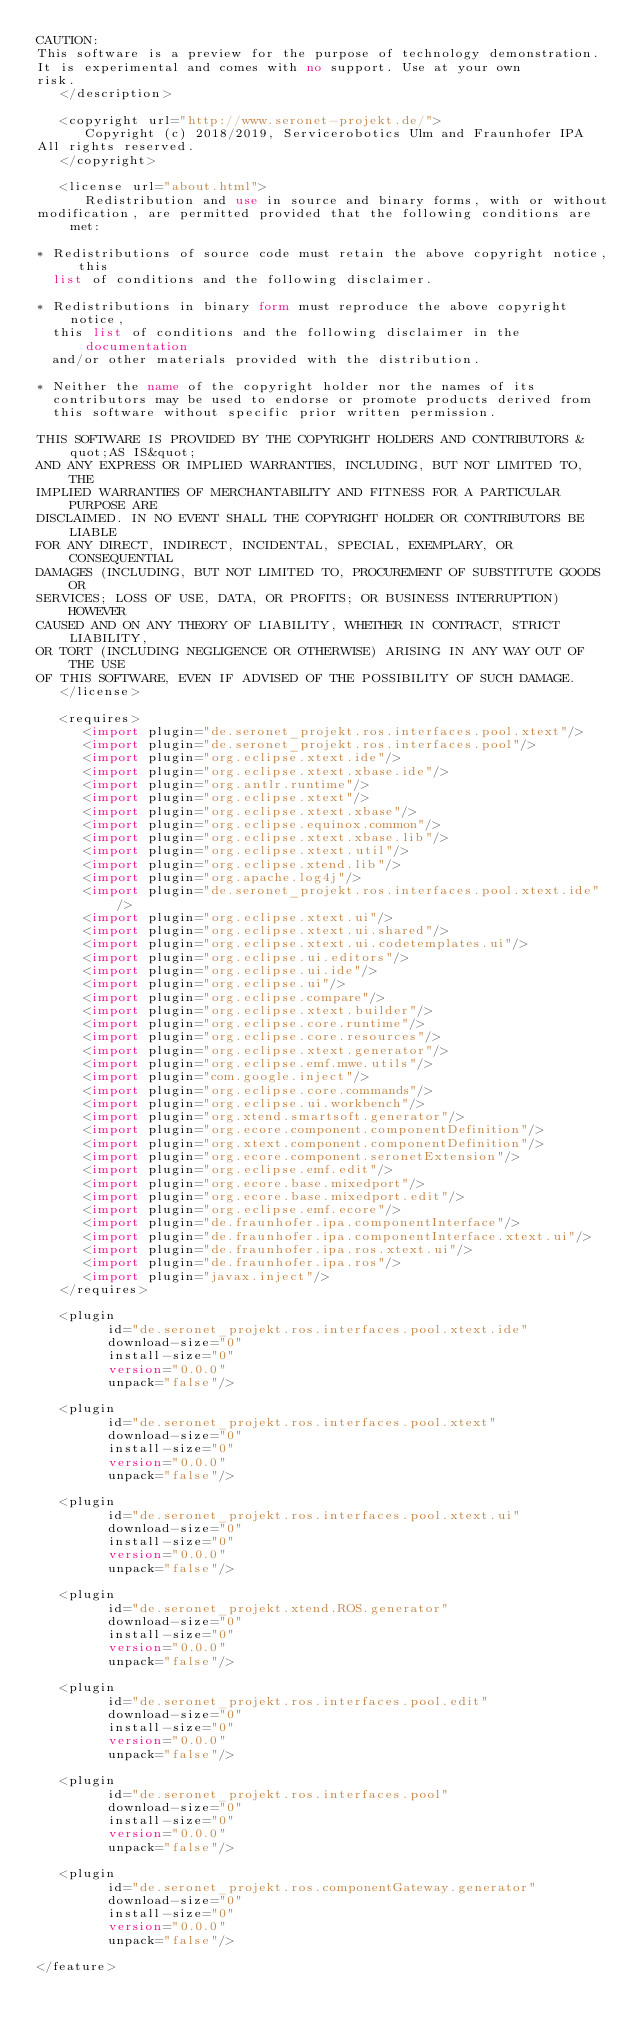Convert code to text. <code><loc_0><loc_0><loc_500><loc_500><_XML_>CAUTION: 
This software is a preview for the purpose of technology demonstration.
It is experimental and comes with no support. Use at your own
risk.
   </description>

   <copyright url="http://www.seronet-projekt.de/">
      Copyright (c) 2018/2019, Servicerobotics Ulm and Fraunhofer IPA
All rights reserved.
   </copyright>

   <license url="about.html">
      Redistribution and use in source and binary forms, with or without
modification, are permitted provided that the following conditions are met:

* Redistributions of source code must retain the above copyright notice, this
  list of conditions and the following disclaimer.

* Redistributions in binary form must reproduce the above copyright notice,
  this list of conditions and the following disclaimer in the documentation
  and/or other materials provided with the distribution.

* Neither the name of the copyright holder nor the names of its
  contributors may be used to endorse or promote products derived from
  this software without specific prior written permission.

THIS SOFTWARE IS PROVIDED BY THE COPYRIGHT HOLDERS AND CONTRIBUTORS &quot;AS IS&quot;
AND ANY EXPRESS OR IMPLIED WARRANTIES, INCLUDING, BUT NOT LIMITED TO, THE
IMPLIED WARRANTIES OF MERCHANTABILITY AND FITNESS FOR A PARTICULAR PURPOSE ARE
DISCLAIMED. IN NO EVENT SHALL THE COPYRIGHT HOLDER OR CONTRIBUTORS BE LIABLE
FOR ANY DIRECT, INDIRECT, INCIDENTAL, SPECIAL, EXEMPLARY, OR CONSEQUENTIAL
DAMAGES (INCLUDING, BUT NOT LIMITED TO, PROCUREMENT OF SUBSTITUTE GOODS OR
SERVICES; LOSS OF USE, DATA, OR PROFITS; OR BUSINESS INTERRUPTION) HOWEVER
CAUSED AND ON ANY THEORY OF LIABILITY, WHETHER IN CONTRACT, STRICT LIABILITY,
OR TORT (INCLUDING NEGLIGENCE OR OTHERWISE) ARISING IN ANY WAY OUT OF THE USE
OF THIS SOFTWARE, EVEN IF ADVISED OF THE POSSIBILITY OF SUCH DAMAGE.
   </license>

   <requires>
      <import plugin="de.seronet_projekt.ros.interfaces.pool.xtext"/>
      <import plugin="de.seronet_projekt.ros.interfaces.pool"/>
      <import plugin="org.eclipse.xtext.ide"/>
      <import plugin="org.eclipse.xtext.xbase.ide"/>
      <import plugin="org.antlr.runtime"/>
      <import plugin="org.eclipse.xtext"/>
      <import plugin="org.eclipse.xtext.xbase"/>
      <import plugin="org.eclipse.equinox.common"/>
      <import plugin="org.eclipse.xtext.xbase.lib"/>
      <import plugin="org.eclipse.xtext.util"/>
      <import plugin="org.eclipse.xtend.lib"/>
      <import plugin="org.apache.log4j"/>
      <import plugin="de.seronet_projekt.ros.interfaces.pool.xtext.ide"/>
      <import plugin="org.eclipse.xtext.ui"/>
      <import plugin="org.eclipse.xtext.ui.shared"/>
      <import plugin="org.eclipse.xtext.ui.codetemplates.ui"/>
      <import plugin="org.eclipse.ui.editors"/>
      <import plugin="org.eclipse.ui.ide"/>
      <import plugin="org.eclipse.ui"/>
      <import plugin="org.eclipse.compare"/>
      <import plugin="org.eclipse.xtext.builder"/>
      <import plugin="org.eclipse.core.runtime"/>
      <import plugin="org.eclipse.core.resources"/>
      <import plugin="org.eclipse.xtext.generator"/>
      <import plugin="org.eclipse.emf.mwe.utils"/>
      <import plugin="com.google.inject"/>
      <import plugin="org.eclipse.core.commands"/>
      <import plugin="org.eclipse.ui.workbench"/>
      <import plugin="org.xtend.smartsoft.generator"/>
      <import plugin="org.ecore.component.componentDefinition"/>
      <import plugin="org.xtext.component.componentDefinition"/>
      <import plugin="org.ecore.component.seronetExtension"/>
      <import plugin="org.eclipse.emf.edit"/>
      <import plugin="org.ecore.base.mixedport"/>
      <import plugin="org.ecore.base.mixedport.edit"/>
      <import plugin="org.eclipse.emf.ecore"/>
      <import plugin="de.fraunhofer.ipa.componentInterface"/>
      <import plugin="de.fraunhofer.ipa.componentInterface.xtext.ui"/>
      <import plugin="de.fraunhofer.ipa.ros.xtext.ui"/>
      <import plugin="de.fraunhofer.ipa.ros"/>
      <import plugin="javax.inject"/>
   </requires>

   <plugin
         id="de.seronet_projekt.ros.interfaces.pool.xtext.ide"
         download-size="0"
         install-size="0"
         version="0.0.0"
         unpack="false"/>

   <plugin
         id="de.seronet_projekt.ros.interfaces.pool.xtext"
         download-size="0"
         install-size="0"
         version="0.0.0"
         unpack="false"/>

   <plugin
         id="de.seronet_projekt.ros.interfaces.pool.xtext.ui"
         download-size="0"
         install-size="0"
         version="0.0.0"
         unpack="false"/>

   <plugin
         id="de.seronet_projekt.xtend.ROS.generator"
         download-size="0"
         install-size="0"
         version="0.0.0"
         unpack="false"/>

   <plugin
         id="de.seronet_projekt.ros.interfaces.pool.edit"
         download-size="0"
         install-size="0"
         version="0.0.0"
         unpack="false"/>

   <plugin
         id="de.seronet_projekt.ros.interfaces.pool"
         download-size="0"
         install-size="0"
         version="0.0.0"
         unpack="false"/>

   <plugin
         id="de.seronet_projekt.ros.componentGateway.generator"
         download-size="0"
         install-size="0"
         version="0.0.0"
         unpack="false"/>

</feature>
</code> 